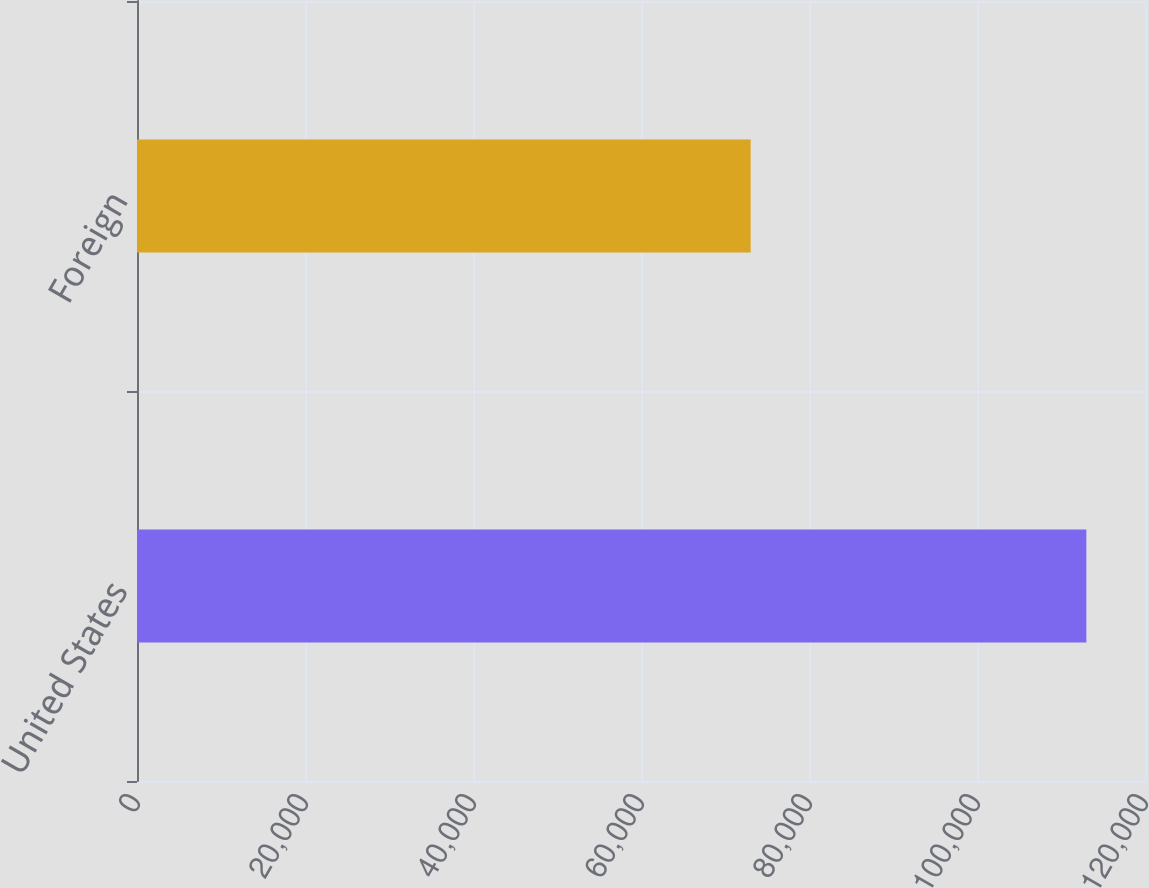<chart> <loc_0><loc_0><loc_500><loc_500><bar_chart><fcel>United States<fcel>Foreign<nl><fcel>113019<fcel>73055<nl></chart> 